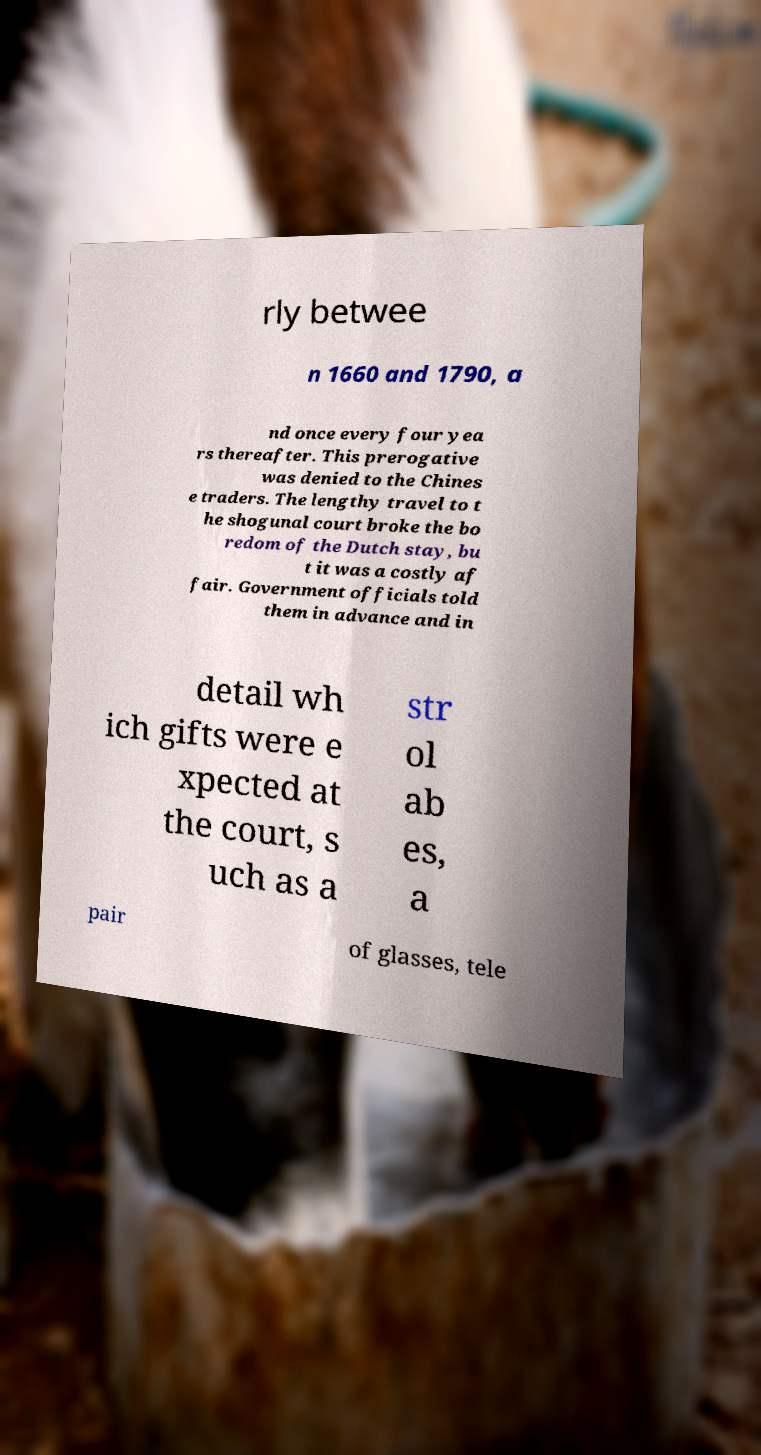I need the written content from this picture converted into text. Can you do that? rly betwee n 1660 and 1790, a nd once every four yea rs thereafter. This prerogative was denied to the Chines e traders. The lengthy travel to t he shogunal court broke the bo redom of the Dutch stay, bu t it was a costly af fair. Government officials told them in advance and in detail wh ich gifts were e xpected at the court, s uch as a str ol ab es, a pair of glasses, tele 